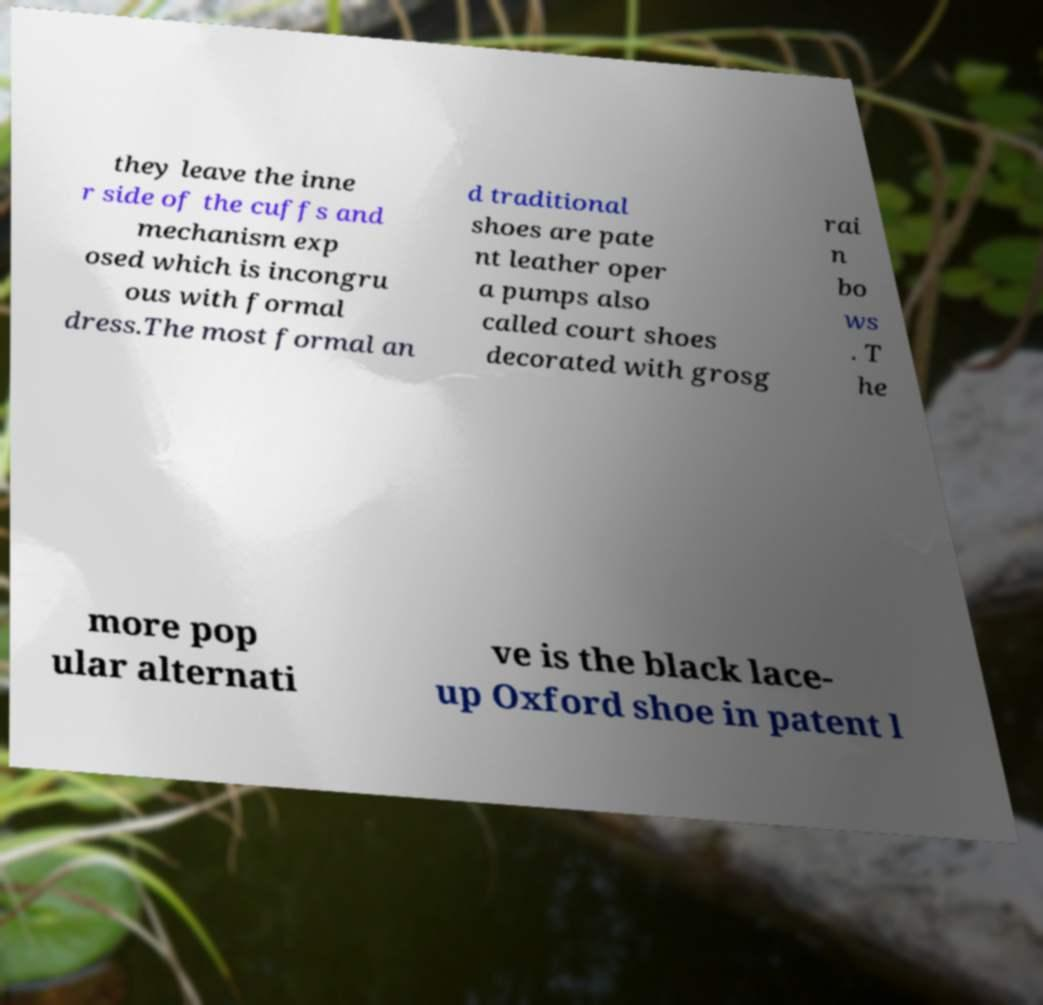What messages or text are displayed in this image? I need them in a readable, typed format. they leave the inne r side of the cuffs and mechanism exp osed which is incongru ous with formal dress.The most formal an d traditional shoes are pate nt leather oper a pumps also called court shoes decorated with grosg rai n bo ws . T he more pop ular alternati ve is the black lace- up Oxford shoe in patent l 